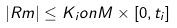Convert formula to latex. <formula><loc_0><loc_0><loc_500><loc_500>| R m | \leq K _ { i } { o n } M \times [ 0 , t _ { i } ]</formula> 